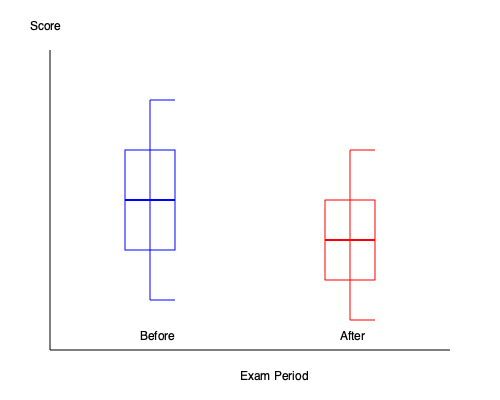Analyze the box plots representing exam score distributions before and after uncovering a cheating ring at a university. What can be inferred about the change in the interquartile range (IQR) and median scores? Additionally, calculate the percentage decrease in the IQR from the "Before" to "After" period. To analyze the box plots and calculate the percentage decrease in IQR, let's follow these steps:

1. Interpret the box plots:
   - The blue box plot represents the "Before" distribution
   - The red box plot represents the "After" distribution

2. Analyze the changes:
   a. Median (represented by the thick line in the box):
      - Before: around the 50th percentile
      - After: slightly higher, around the 60th percentile
   b. IQR (represented by the height of the box):
      - Before: larger box, indicating greater variability
      - After: smaller box, indicating less variability

3. Calculate the IQR for each distribution:
   Let's assume the y-axis scale is from 0 to 100.
   a. Before IQR:
      - Q3 (top of box): approximately 75
      - Q1 (bottom of box): approximately 50
      - IQR_before = 75 - 50 = 25
   b. After IQR:
      - Q3 (top of box): approximately 70
      - Q1 (bottom of box): approximately 60
      - IQR_after = 70 - 60 = 10

4. Calculate the percentage decrease in IQR:
   Percentage decrease = $\frac{\text{IQR_before} - \text{IQR_after}}{\text{IQR_before}} \times 100\%$
   
   $= \frac{25 - 10}{25} \times 100\% = \frac{15}{25} \times 100\% = 60\%$

5. Interpretation:
   - The median score increased slightly after uncovering the cheating ring.
   - The IQR decreased significantly, indicating less variability in scores.
   - The IQR decreased by 60%, suggesting a more consistent performance across students after addressing the cheating issue.
Answer: Median increased slightly; IQR decreased by 60%, indicating less variability and more consistent performance after addressing cheating. 